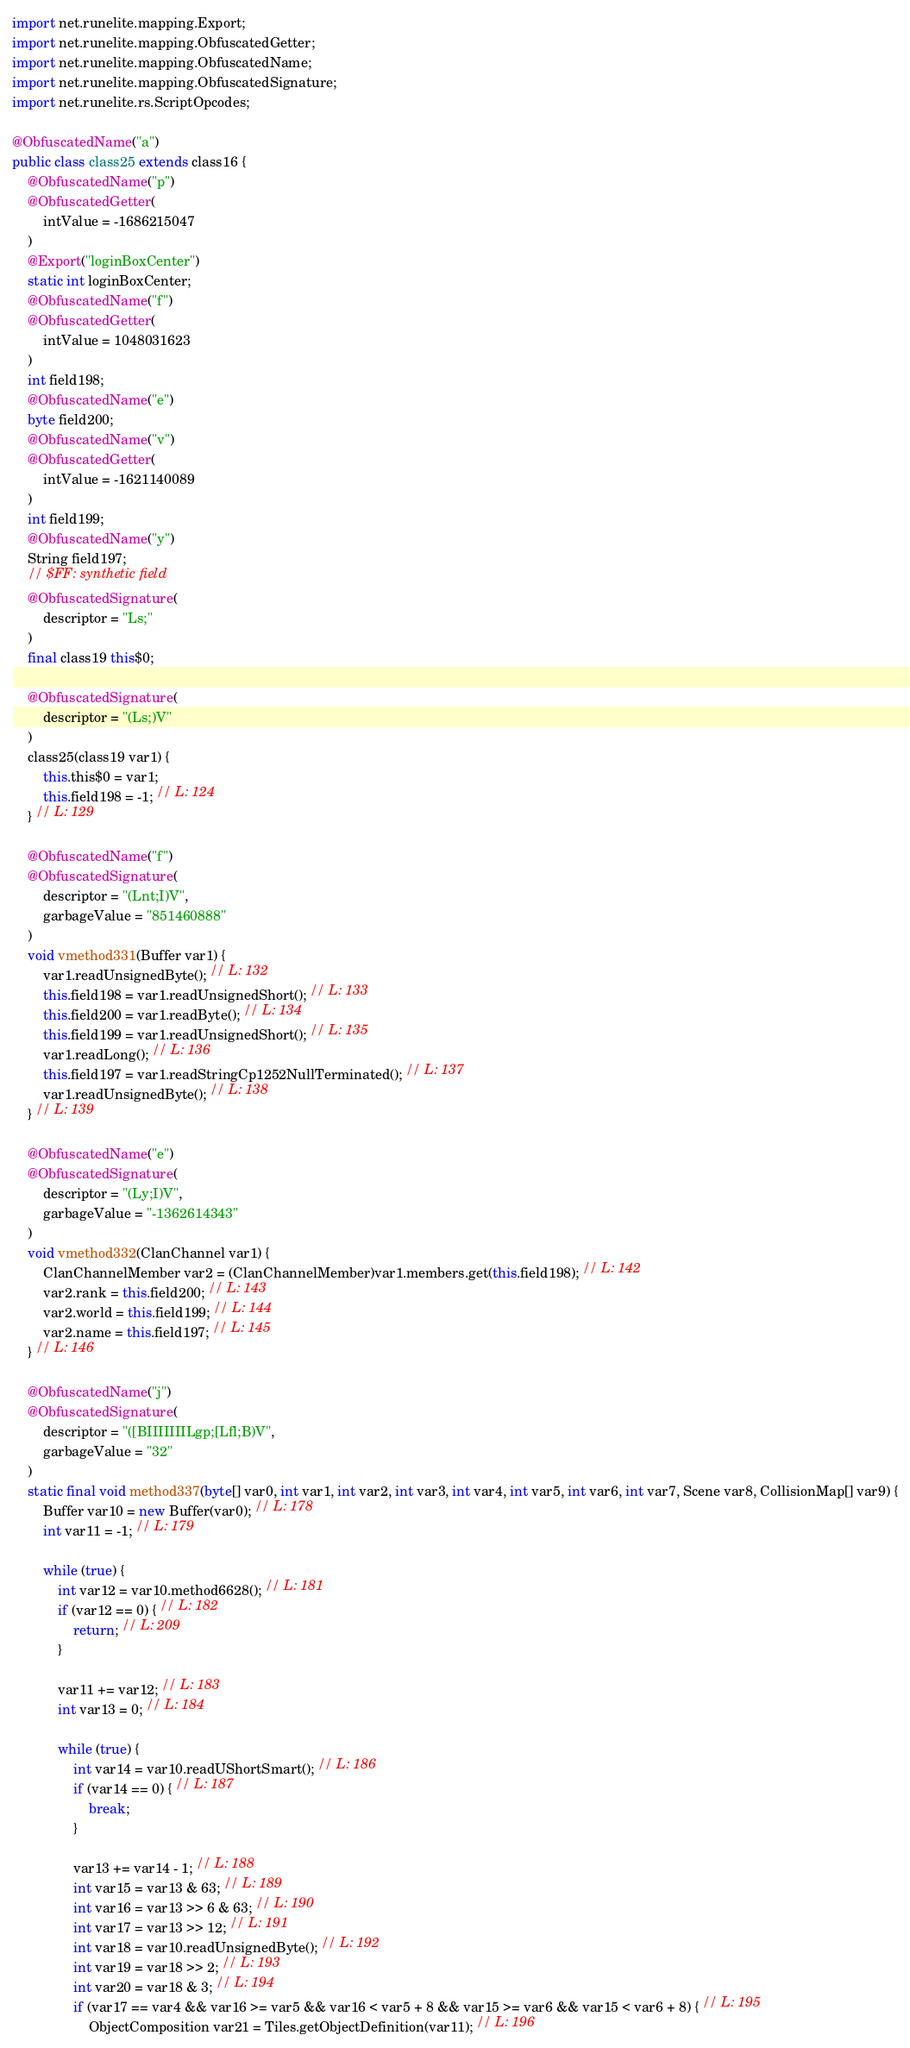<code> <loc_0><loc_0><loc_500><loc_500><_Java_>import net.runelite.mapping.Export;
import net.runelite.mapping.ObfuscatedGetter;
import net.runelite.mapping.ObfuscatedName;
import net.runelite.mapping.ObfuscatedSignature;
import net.runelite.rs.ScriptOpcodes;

@ObfuscatedName("a")
public class class25 extends class16 {
	@ObfuscatedName("p")
	@ObfuscatedGetter(
		intValue = -1686215047
	)
	@Export("loginBoxCenter")
	static int loginBoxCenter;
	@ObfuscatedName("f")
	@ObfuscatedGetter(
		intValue = 1048031623
	)
	int field198;
	@ObfuscatedName("e")
	byte field200;
	@ObfuscatedName("v")
	@ObfuscatedGetter(
		intValue = -1621140089
	)
	int field199;
	@ObfuscatedName("y")
	String field197;
	// $FF: synthetic field
	@ObfuscatedSignature(
		descriptor = "Ls;"
	)
	final class19 this$0;

	@ObfuscatedSignature(
		descriptor = "(Ls;)V"
	)
	class25(class19 var1) {
		this.this$0 = var1;
		this.field198 = -1; // L: 124
	} // L: 129

	@ObfuscatedName("f")
	@ObfuscatedSignature(
		descriptor = "(Lnt;I)V",
		garbageValue = "851460888"
	)
	void vmethod331(Buffer var1) {
		var1.readUnsignedByte(); // L: 132
		this.field198 = var1.readUnsignedShort(); // L: 133
		this.field200 = var1.readByte(); // L: 134
		this.field199 = var1.readUnsignedShort(); // L: 135
		var1.readLong(); // L: 136
		this.field197 = var1.readStringCp1252NullTerminated(); // L: 137
		var1.readUnsignedByte(); // L: 138
	} // L: 139

	@ObfuscatedName("e")
	@ObfuscatedSignature(
		descriptor = "(Ly;I)V",
		garbageValue = "-1362614343"
	)
	void vmethod332(ClanChannel var1) {
		ClanChannelMember var2 = (ClanChannelMember)var1.members.get(this.field198); // L: 142
		var2.rank = this.field200; // L: 143
		var2.world = this.field199; // L: 144
		var2.name = this.field197; // L: 145
	} // L: 146

	@ObfuscatedName("j")
	@ObfuscatedSignature(
		descriptor = "([BIIIIIIILgp;[Lfl;B)V",
		garbageValue = "32"
	)
	static final void method337(byte[] var0, int var1, int var2, int var3, int var4, int var5, int var6, int var7, Scene var8, CollisionMap[] var9) {
		Buffer var10 = new Buffer(var0); // L: 178
		int var11 = -1; // L: 179

		while (true) {
			int var12 = var10.method6628(); // L: 181
			if (var12 == 0) { // L: 182
				return; // L: 209
			}

			var11 += var12; // L: 183
			int var13 = 0; // L: 184

			while (true) {
				int var14 = var10.readUShortSmart(); // L: 186
				if (var14 == 0) { // L: 187
					break;
				}

				var13 += var14 - 1; // L: 188
				int var15 = var13 & 63; // L: 189
				int var16 = var13 >> 6 & 63; // L: 190
				int var17 = var13 >> 12; // L: 191
				int var18 = var10.readUnsignedByte(); // L: 192
				int var19 = var18 >> 2; // L: 193
				int var20 = var18 & 3; // L: 194
				if (var17 == var4 && var16 >= var5 && var16 < var5 + 8 && var15 >= var6 && var15 < var6 + 8) { // L: 195
					ObjectComposition var21 = Tiles.getObjectDefinition(var11); // L: 196</code> 